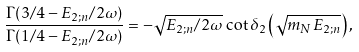<formula> <loc_0><loc_0><loc_500><loc_500>\frac { \Gamma ( 3 / 4 - E _ { 2 ; n } / 2 \omega ) } { \Gamma ( 1 / 4 - E _ { 2 ; n } / 2 \omega ) } = - \sqrt { E _ { 2 ; n } / 2 \omega } \, \cot \delta _ { 2 } \left ( \sqrt { m _ { N } E _ { 2 ; n } } \right ) ,</formula> 